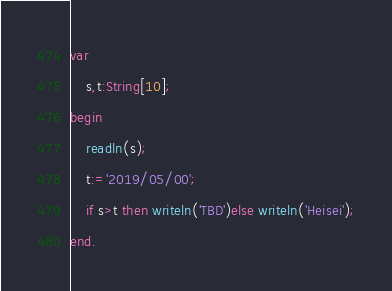Convert code to text. <code><loc_0><loc_0><loc_500><loc_500><_Pascal_>var
	s,t:String[10];
begin
	readln(s);
	t:='2019/05/00';
	if s>t then writeln('TBD')else writeln('Heisei');
end.</code> 